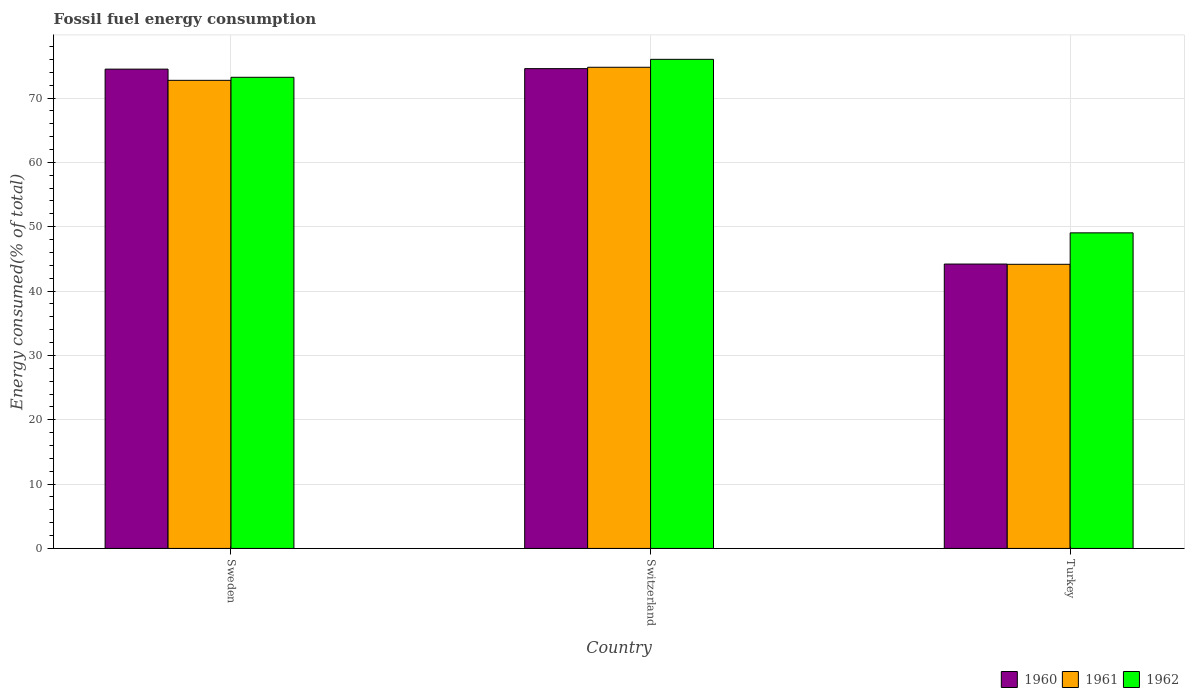How many different coloured bars are there?
Your answer should be very brief. 3. Are the number of bars per tick equal to the number of legend labels?
Offer a terse response. Yes. How many bars are there on the 3rd tick from the left?
Make the answer very short. 3. How many bars are there on the 1st tick from the right?
Provide a succinct answer. 3. What is the label of the 1st group of bars from the left?
Keep it short and to the point. Sweden. What is the percentage of energy consumed in 1962 in Turkey?
Keep it short and to the point. 49.05. Across all countries, what is the maximum percentage of energy consumed in 1961?
Your answer should be compact. 74.78. Across all countries, what is the minimum percentage of energy consumed in 1960?
Provide a short and direct response. 44.2. In which country was the percentage of energy consumed in 1961 maximum?
Provide a short and direct response. Switzerland. What is the total percentage of energy consumed in 1960 in the graph?
Keep it short and to the point. 193.26. What is the difference between the percentage of energy consumed in 1961 in Switzerland and that in Turkey?
Ensure brevity in your answer.  30.62. What is the difference between the percentage of energy consumed in 1962 in Switzerland and the percentage of energy consumed in 1961 in Turkey?
Keep it short and to the point. 31.86. What is the average percentage of energy consumed in 1961 per country?
Your answer should be compact. 63.9. What is the difference between the percentage of energy consumed of/in 1960 and percentage of energy consumed of/in 1961 in Switzerland?
Provide a succinct answer. -0.21. What is the ratio of the percentage of energy consumed in 1961 in Sweden to that in Turkey?
Ensure brevity in your answer.  1.65. Is the percentage of energy consumed in 1962 in Sweden less than that in Switzerland?
Give a very brief answer. Yes. Is the difference between the percentage of energy consumed in 1960 in Sweden and Turkey greater than the difference between the percentage of energy consumed in 1961 in Sweden and Turkey?
Provide a short and direct response. Yes. What is the difference between the highest and the second highest percentage of energy consumed in 1960?
Ensure brevity in your answer.  30.37. What is the difference between the highest and the lowest percentage of energy consumed in 1962?
Your response must be concise. 26.97. In how many countries, is the percentage of energy consumed in 1962 greater than the average percentage of energy consumed in 1962 taken over all countries?
Offer a very short reply. 2. Are the values on the major ticks of Y-axis written in scientific E-notation?
Your answer should be compact. No. Does the graph contain any zero values?
Make the answer very short. No. Does the graph contain grids?
Offer a terse response. Yes. How many legend labels are there?
Ensure brevity in your answer.  3. How are the legend labels stacked?
Give a very brief answer. Horizontal. What is the title of the graph?
Keep it short and to the point. Fossil fuel energy consumption. What is the label or title of the Y-axis?
Provide a short and direct response. Energy consumed(% of total). What is the Energy consumed(% of total) in 1960 in Sweden?
Ensure brevity in your answer.  74.49. What is the Energy consumed(% of total) of 1961 in Sweden?
Offer a terse response. 72.75. What is the Energy consumed(% of total) of 1962 in Sweden?
Your response must be concise. 73.23. What is the Energy consumed(% of total) of 1960 in Switzerland?
Give a very brief answer. 74.57. What is the Energy consumed(% of total) in 1961 in Switzerland?
Ensure brevity in your answer.  74.78. What is the Energy consumed(% of total) of 1962 in Switzerland?
Ensure brevity in your answer.  76.02. What is the Energy consumed(% of total) in 1960 in Turkey?
Make the answer very short. 44.2. What is the Energy consumed(% of total) in 1961 in Turkey?
Give a very brief answer. 44.16. What is the Energy consumed(% of total) in 1962 in Turkey?
Your answer should be compact. 49.05. Across all countries, what is the maximum Energy consumed(% of total) in 1960?
Your answer should be compact. 74.57. Across all countries, what is the maximum Energy consumed(% of total) of 1961?
Ensure brevity in your answer.  74.78. Across all countries, what is the maximum Energy consumed(% of total) in 1962?
Offer a terse response. 76.02. Across all countries, what is the minimum Energy consumed(% of total) of 1960?
Your answer should be compact. 44.2. Across all countries, what is the minimum Energy consumed(% of total) in 1961?
Make the answer very short. 44.16. Across all countries, what is the minimum Energy consumed(% of total) of 1962?
Provide a short and direct response. 49.05. What is the total Energy consumed(% of total) of 1960 in the graph?
Ensure brevity in your answer.  193.26. What is the total Energy consumed(% of total) of 1961 in the graph?
Provide a succinct answer. 191.7. What is the total Energy consumed(% of total) of 1962 in the graph?
Your response must be concise. 198.29. What is the difference between the Energy consumed(% of total) of 1960 in Sweden and that in Switzerland?
Provide a short and direct response. -0.08. What is the difference between the Energy consumed(% of total) in 1961 in Sweden and that in Switzerland?
Keep it short and to the point. -2.03. What is the difference between the Energy consumed(% of total) of 1962 in Sweden and that in Switzerland?
Your answer should be very brief. -2.79. What is the difference between the Energy consumed(% of total) in 1960 in Sweden and that in Turkey?
Keep it short and to the point. 30.29. What is the difference between the Energy consumed(% of total) of 1961 in Sweden and that in Turkey?
Provide a succinct answer. 28.59. What is the difference between the Energy consumed(% of total) of 1962 in Sweden and that in Turkey?
Offer a very short reply. 24.18. What is the difference between the Energy consumed(% of total) in 1960 in Switzerland and that in Turkey?
Give a very brief answer. 30.37. What is the difference between the Energy consumed(% of total) in 1961 in Switzerland and that in Turkey?
Offer a very short reply. 30.62. What is the difference between the Energy consumed(% of total) of 1962 in Switzerland and that in Turkey?
Your answer should be very brief. 26.97. What is the difference between the Energy consumed(% of total) of 1960 in Sweden and the Energy consumed(% of total) of 1961 in Switzerland?
Offer a terse response. -0.29. What is the difference between the Energy consumed(% of total) in 1960 in Sweden and the Energy consumed(% of total) in 1962 in Switzerland?
Offer a very short reply. -1.52. What is the difference between the Energy consumed(% of total) in 1961 in Sweden and the Energy consumed(% of total) in 1962 in Switzerland?
Offer a terse response. -3.26. What is the difference between the Energy consumed(% of total) in 1960 in Sweden and the Energy consumed(% of total) in 1961 in Turkey?
Offer a very short reply. 30.33. What is the difference between the Energy consumed(% of total) of 1960 in Sweden and the Energy consumed(% of total) of 1962 in Turkey?
Keep it short and to the point. 25.44. What is the difference between the Energy consumed(% of total) of 1961 in Sweden and the Energy consumed(% of total) of 1962 in Turkey?
Offer a terse response. 23.7. What is the difference between the Energy consumed(% of total) in 1960 in Switzerland and the Energy consumed(% of total) in 1961 in Turkey?
Provide a short and direct response. 30.41. What is the difference between the Energy consumed(% of total) of 1960 in Switzerland and the Energy consumed(% of total) of 1962 in Turkey?
Your answer should be very brief. 25.52. What is the difference between the Energy consumed(% of total) in 1961 in Switzerland and the Energy consumed(% of total) in 1962 in Turkey?
Keep it short and to the point. 25.73. What is the average Energy consumed(% of total) of 1960 per country?
Provide a short and direct response. 64.42. What is the average Energy consumed(% of total) of 1961 per country?
Your answer should be very brief. 63.9. What is the average Energy consumed(% of total) of 1962 per country?
Offer a very short reply. 66.1. What is the difference between the Energy consumed(% of total) in 1960 and Energy consumed(% of total) in 1961 in Sweden?
Keep it short and to the point. 1.74. What is the difference between the Energy consumed(% of total) of 1960 and Energy consumed(% of total) of 1962 in Sweden?
Ensure brevity in your answer.  1.27. What is the difference between the Energy consumed(% of total) of 1961 and Energy consumed(% of total) of 1962 in Sweden?
Provide a short and direct response. -0.47. What is the difference between the Energy consumed(% of total) in 1960 and Energy consumed(% of total) in 1961 in Switzerland?
Give a very brief answer. -0.21. What is the difference between the Energy consumed(% of total) of 1960 and Energy consumed(% of total) of 1962 in Switzerland?
Your answer should be very brief. -1.45. What is the difference between the Energy consumed(% of total) in 1961 and Energy consumed(% of total) in 1962 in Switzerland?
Provide a succinct answer. -1.23. What is the difference between the Energy consumed(% of total) of 1960 and Energy consumed(% of total) of 1961 in Turkey?
Keep it short and to the point. 0.04. What is the difference between the Energy consumed(% of total) in 1960 and Energy consumed(% of total) in 1962 in Turkey?
Your response must be concise. -4.85. What is the difference between the Energy consumed(% of total) of 1961 and Energy consumed(% of total) of 1962 in Turkey?
Give a very brief answer. -4.89. What is the ratio of the Energy consumed(% of total) of 1960 in Sweden to that in Switzerland?
Provide a succinct answer. 1. What is the ratio of the Energy consumed(% of total) in 1961 in Sweden to that in Switzerland?
Give a very brief answer. 0.97. What is the ratio of the Energy consumed(% of total) of 1962 in Sweden to that in Switzerland?
Your response must be concise. 0.96. What is the ratio of the Energy consumed(% of total) of 1960 in Sweden to that in Turkey?
Your response must be concise. 1.69. What is the ratio of the Energy consumed(% of total) in 1961 in Sweden to that in Turkey?
Ensure brevity in your answer.  1.65. What is the ratio of the Energy consumed(% of total) in 1962 in Sweden to that in Turkey?
Your response must be concise. 1.49. What is the ratio of the Energy consumed(% of total) in 1960 in Switzerland to that in Turkey?
Your answer should be compact. 1.69. What is the ratio of the Energy consumed(% of total) in 1961 in Switzerland to that in Turkey?
Offer a terse response. 1.69. What is the ratio of the Energy consumed(% of total) of 1962 in Switzerland to that in Turkey?
Give a very brief answer. 1.55. What is the difference between the highest and the second highest Energy consumed(% of total) in 1960?
Your answer should be compact. 0.08. What is the difference between the highest and the second highest Energy consumed(% of total) in 1961?
Offer a terse response. 2.03. What is the difference between the highest and the second highest Energy consumed(% of total) of 1962?
Give a very brief answer. 2.79. What is the difference between the highest and the lowest Energy consumed(% of total) in 1960?
Your answer should be compact. 30.37. What is the difference between the highest and the lowest Energy consumed(% of total) in 1961?
Make the answer very short. 30.62. What is the difference between the highest and the lowest Energy consumed(% of total) in 1962?
Keep it short and to the point. 26.97. 